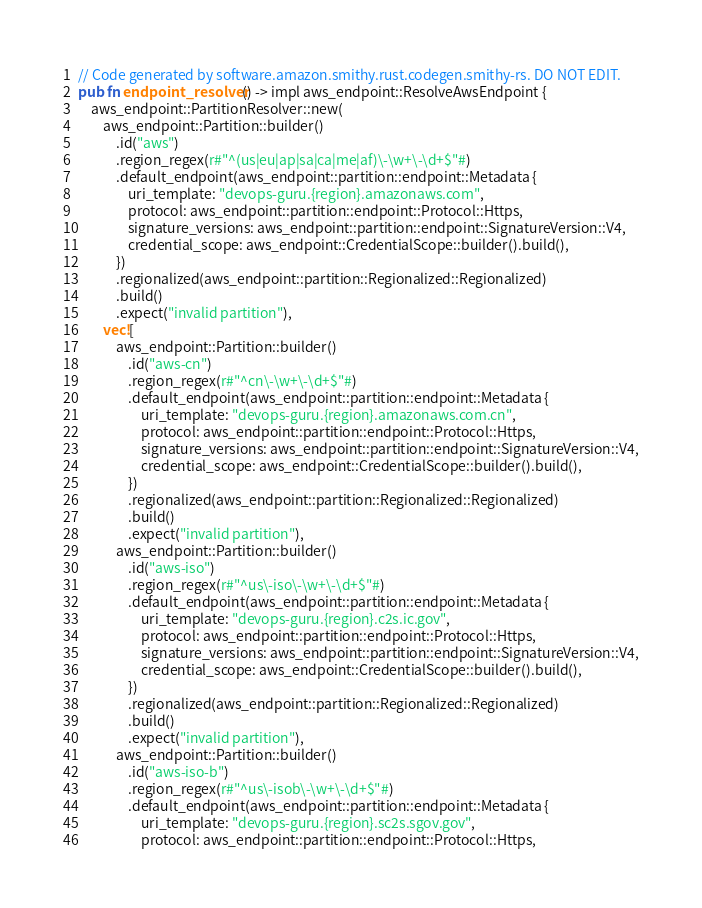Convert code to text. <code><loc_0><loc_0><loc_500><loc_500><_Rust_>// Code generated by software.amazon.smithy.rust.codegen.smithy-rs. DO NOT EDIT.
pub fn endpoint_resolver() -> impl aws_endpoint::ResolveAwsEndpoint {
    aws_endpoint::PartitionResolver::new(
        aws_endpoint::Partition::builder()
            .id("aws")
            .region_regex(r#"^(us|eu|ap|sa|ca|me|af)\-\w+\-\d+$"#)
            .default_endpoint(aws_endpoint::partition::endpoint::Metadata {
                uri_template: "devops-guru.{region}.amazonaws.com",
                protocol: aws_endpoint::partition::endpoint::Protocol::Https,
                signature_versions: aws_endpoint::partition::endpoint::SignatureVersion::V4,
                credential_scope: aws_endpoint::CredentialScope::builder().build(),
            })
            .regionalized(aws_endpoint::partition::Regionalized::Regionalized)
            .build()
            .expect("invalid partition"),
        vec![
            aws_endpoint::Partition::builder()
                .id("aws-cn")
                .region_regex(r#"^cn\-\w+\-\d+$"#)
                .default_endpoint(aws_endpoint::partition::endpoint::Metadata {
                    uri_template: "devops-guru.{region}.amazonaws.com.cn",
                    protocol: aws_endpoint::partition::endpoint::Protocol::Https,
                    signature_versions: aws_endpoint::partition::endpoint::SignatureVersion::V4,
                    credential_scope: aws_endpoint::CredentialScope::builder().build(),
                })
                .regionalized(aws_endpoint::partition::Regionalized::Regionalized)
                .build()
                .expect("invalid partition"),
            aws_endpoint::Partition::builder()
                .id("aws-iso")
                .region_regex(r#"^us\-iso\-\w+\-\d+$"#)
                .default_endpoint(aws_endpoint::partition::endpoint::Metadata {
                    uri_template: "devops-guru.{region}.c2s.ic.gov",
                    protocol: aws_endpoint::partition::endpoint::Protocol::Https,
                    signature_versions: aws_endpoint::partition::endpoint::SignatureVersion::V4,
                    credential_scope: aws_endpoint::CredentialScope::builder().build(),
                })
                .regionalized(aws_endpoint::partition::Regionalized::Regionalized)
                .build()
                .expect("invalid partition"),
            aws_endpoint::Partition::builder()
                .id("aws-iso-b")
                .region_regex(r#"^us\-isob\-\w+\-\d+$"#)
                .default_endpoint(aws_endpoint::partition::endpoint::Metadata {
                    uri_template: "devops-guru.{region}.sc2s.sgov.gov",
                    protocol: aws_endpoint::partition::endpoint::Protocol::Https,</code> 